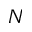<formula> <loc_0><loc_0><loc_500><loc_500>N</formula> 